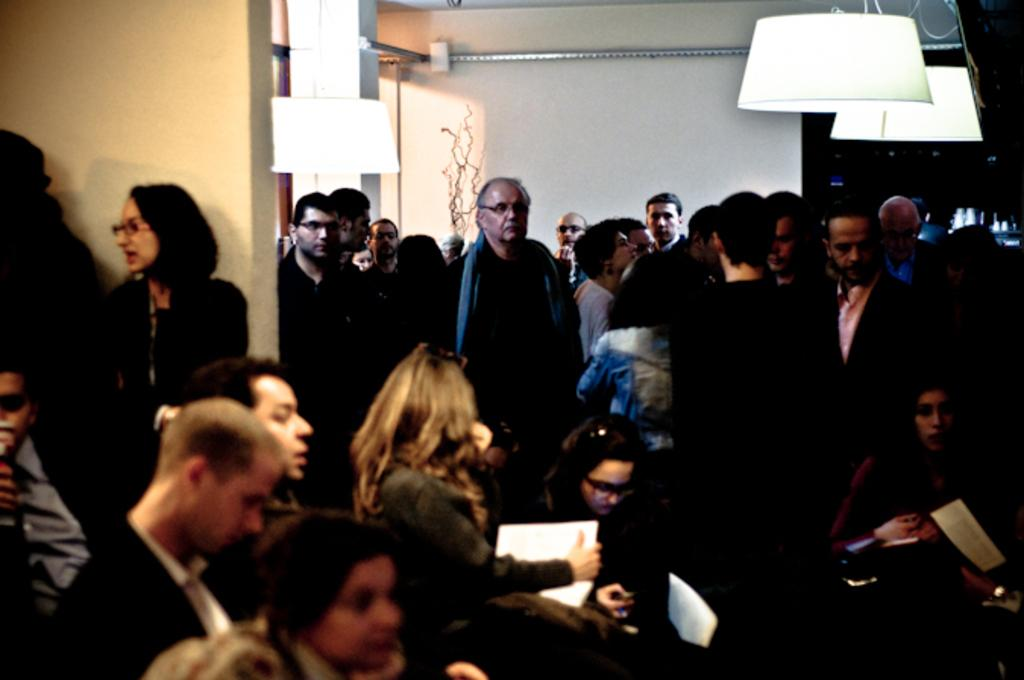How many people are in the group visible in the image? There is a group of people in the image, but the exact number is not specified. What are the papers used for in the image? The purpose of the papers in the image is not clear, but they are present. What type of lighting is visible in the image? There are lights in the image, but their specific type is not mentioned. What is the pillar supporting or holding up in the image? The purpose or function of the pillar in the image is not specified. Can you describe the objects in the image? There are some objects in the image, but their specific nature is not mentioned. What can be seen in the background of the image? There is a wall in the background of the image. What color is the sweater worn by the rat in the image? There is no rat or sweater present in the image. What type of town is visible in the background of the image? The image does not show a town or any background beyond the wall. 